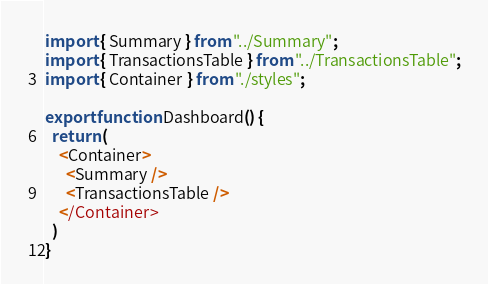<code> <loc_0><loc_0><loc_500><loc_500><_TypeScript_>import { Summary } from "../Summary";
import { TransactionsTable } from "../TransactionsTable";
import { Container } from "./styles";

export function Dashboard() {
  return (
    <Container>
      <Summary />
      <TransactionsTable />
    </Container>
  )
}
</code> 